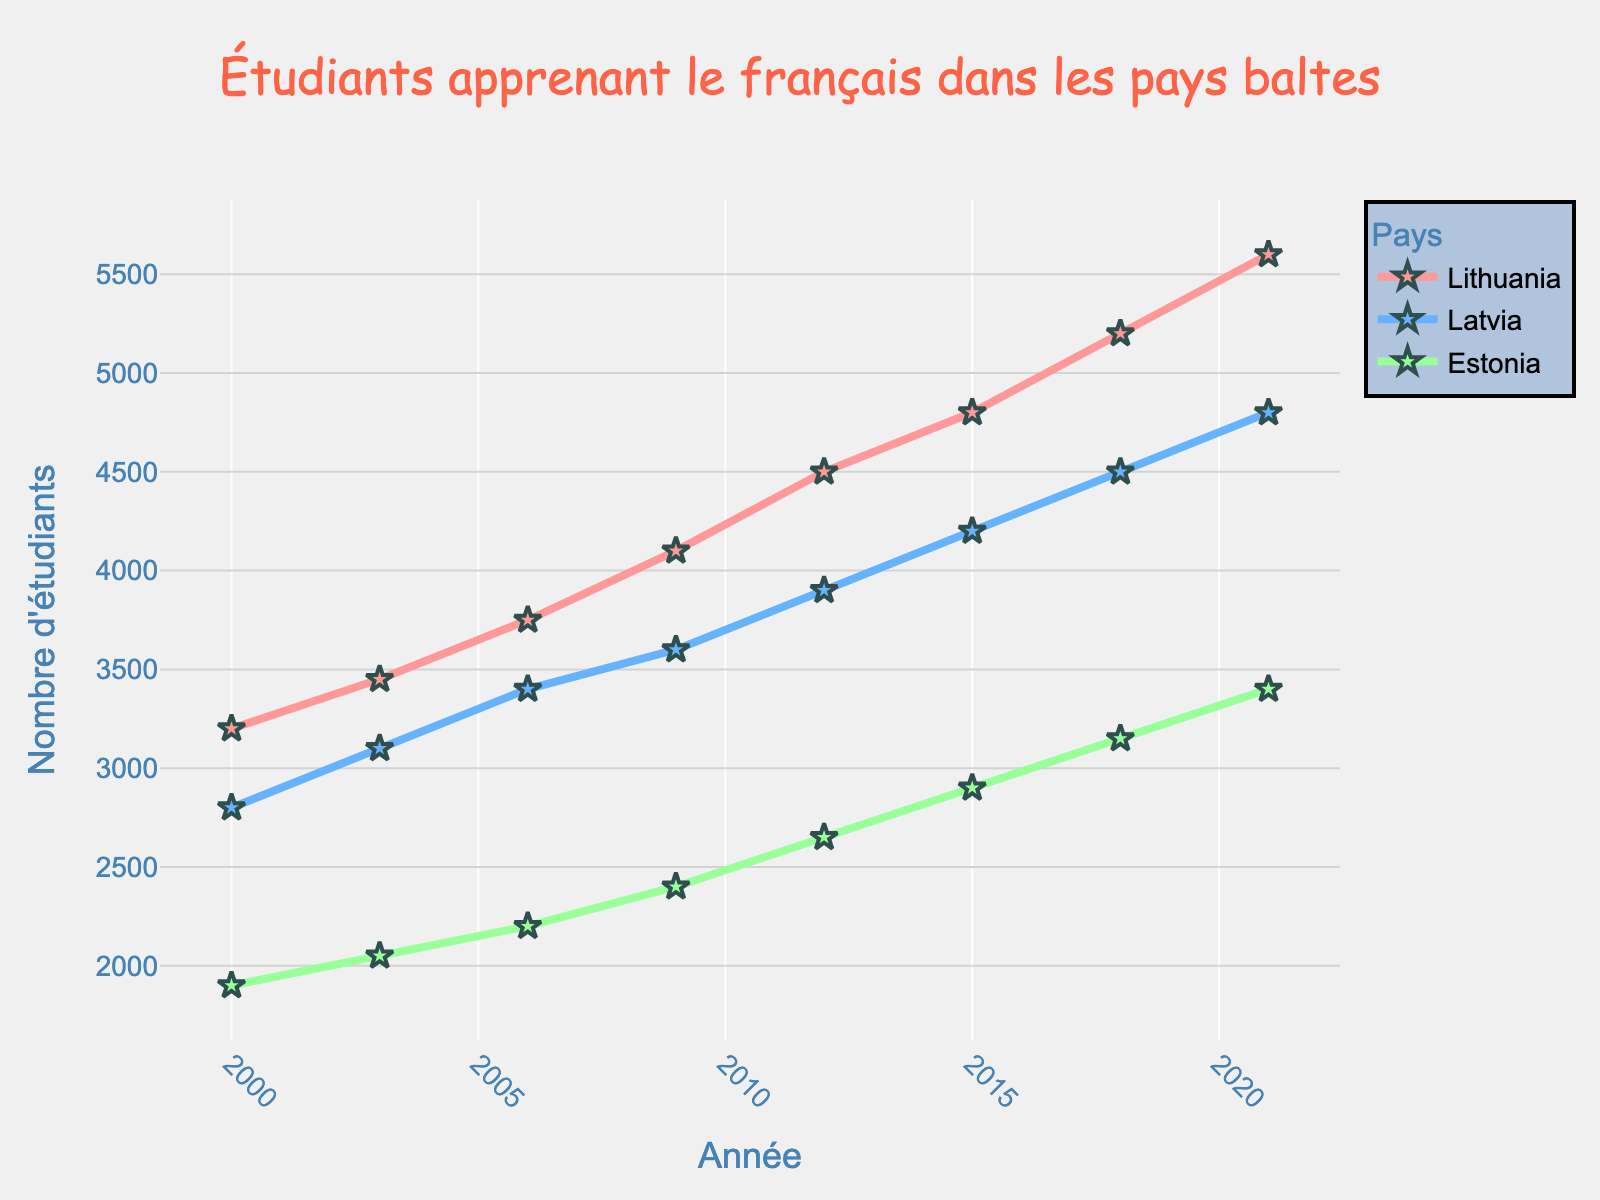What's the highest number of students learning French in a single year and country? The graph shows student numbers over the years for each country. The highest value is in 2021 for Lithuania, reaching 5600 students.
Answer: 5600 Which country had the lowest number of students in 2006? By observing the data points for 2006, Estonia had the lowest number of students learning French, with 2200 students.
Answer: Estonia What is the overall trend for Latvia from 2000 to 2021? The student numbers for Latvia steadily increase from 2800 in 2000 to 4800 in 2021. Therefore, the trend for Latvia is an upward one.
Answer: Upward By how much did the number of students in Lithuania increase from 2000 to 2021? Student numbers in Lithuania increased from 3200 in 2000 to 5600 in 2021. The increase is 5600 - 3200 = 2400 students.
Answer: 2400 What is the average number of students learning French in Estonia over all years given? The numbers for Estonia are 1900, 2050, 2200, 2400, 2650, 2900, 3150, and 3400. Summing them gives 20850. Dividing by 8 (the number of years) results in 20850 / 8 = 2606.25.
Answer: 2606.25 Compare the student growth in Lithuania and Latvia from 2015 to 2021. Which country had a higher increase? The student numbers in Lithuania grew from 4800 to 5600, an increase of 800. In Latvia, the numbers grew from 4200 to 4800, an increase of 600. Therefore, Lithuania had a higher increase.
Answer: Lithuania What can you infer about the relative growth rates of these languages over time by comparing the slopes of the lines? Lithuania's line is steepest, indicating its rate of increase is the highest. Latvia also has a consistent upward slope, while Estonia’s rate is the slowest but still increasing. Hence, Lithuania has the highest growth rate.
Answer: Lithuania When did Latvia surpass the number of students learning French compared to Estonia? In 2000, Latvia had 2800 students, while Estonia had 1900. Latvia had more students learning French than Estonia from the beginning.
Answer: 2000 